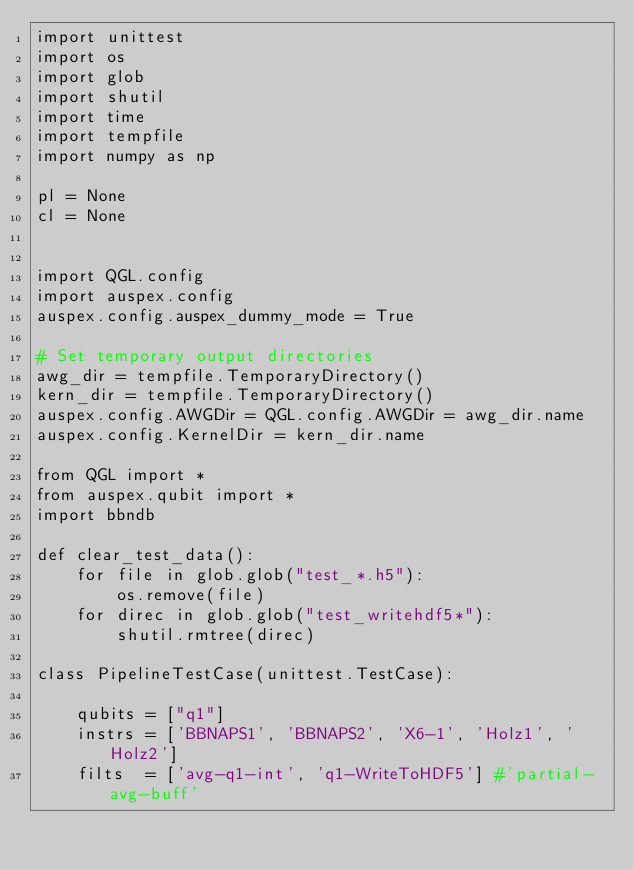<code> <loc_0><loc_0><loc_500><loc_500><_Python_>import unittest
import os
import glob
import shutil
import time
import tempfile
import numpy as np

pl = None
cl = None


import QGL.config
import auspex.config
auspex.config.auspex_dummy_mode = True

# Set temporary output directories
awg_dir = tempfile.TemporaryDirectory()
kern_dir = tempfile.TemporaryDirectory()
auspex.config.AWGDir = QGL.config.AWGDir = awg_dir.name
auspex.config.KernelDir = kern_dir.name

from QGL import *
from auspex.qubit import *
import bbndb

def clear_test_data():
    for file in glob.glob("test_*.h5"):
        os.remove(file)
    for direc in glob.glob("test_writehdf5*"):
        shutil.rmtree(direc)

class PipelineTestCase(unittest.TestCase):

    qubits = ["q1"]
    instrs = ['BBNAPS1', 'BBNAPS2', 'X6-1', 'Holz1', 'Holz2']
    filts  = ['avg-q1-int', 'q1-WriteToHDF5'] #'partial-avg-buff'</code> 